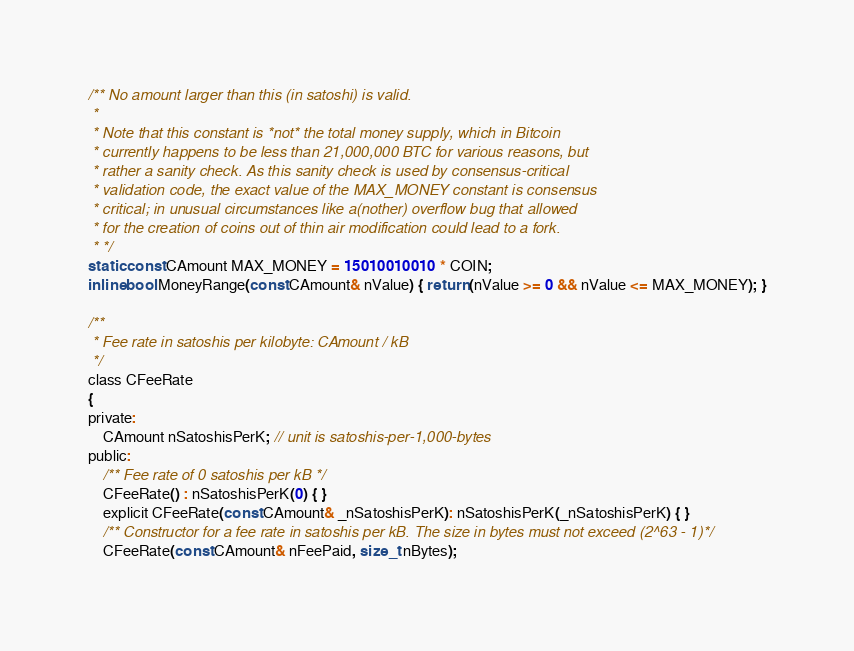Convert code to text. <code><loc_0><loc_0><loc_500><loc_500><_C_>
/** No amount larger than this (in satoshi) is valid.
 *
 * Note that this constant is *not* the total money supply, which in Bitcoin
 * currently happens to be less than 21,000,000 BTC for various reasons, but
 * rather a sanity check. As this sanity check is used by consensus-critical
 * validation code, the exact value of the MAX_MONEY constant is consensus
 * critical; in unusual circumstances like a(nother) overflow bug that allowed
 * for the creation of coins out of thin air modification could lead to a fork.
 * */
static const CAmount MAX_MONEY = 15010010010 * COIN;
inline bool MoneyRange(const CAmount& nValue) { return (nValue >= 0 && nValue <= MAX_MONEY); }

/**
 * Fee rate in satoshis per kilobyte: CAmount / kB
 */
class CFeeRate
{
private:
    CAmount nSatoshisPerK; // unit is satoshis-per-1,000-bytes
public:
    /** Fee rate of 0 satoshis per kB */
    CFeeRate() : nSatoshisPerK(0) { }
    explicit CFeeRate(const CAmount& _nSatoshisPerK): nSatoshisPerK(_nSatoshisPerK) { }
    /** Constructor for a fee rate in satoshis per kB. The size in bytes must not exceed (2^63 - 1)*/
    CFeeRate(const CAmount& nFeePaid, size_t nBytes);</code> 